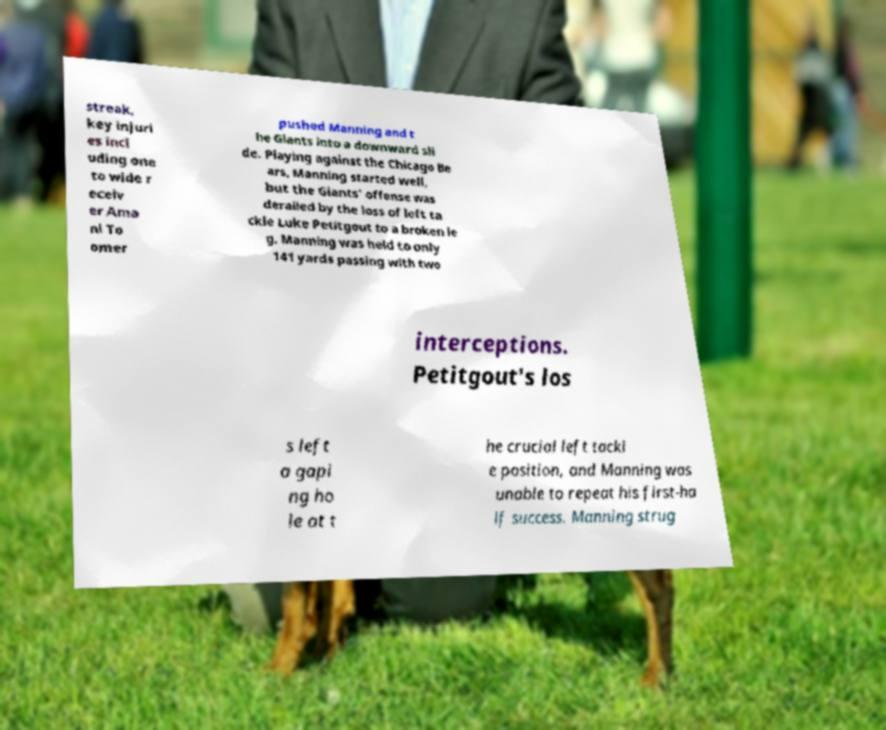Please identify and transcribe the text found in this image. streak, key injuri es incl uding one to wide r eceiv er Ama ni To omer pushed Manning and t he Giants into a downward sli de. Playing against the Chicago Be ars, Manning started well, but the Giants' offense was derailed by the loss of left ta ckle Luke Petitgout to a broken le g. Manning was held to only 141 yards passing with two interceptions. Petitgout's los s left a gapi ng ho le at t he crucial left tackl e position, and Manning was unable to repeat his first-ha lf success. Manning strug 